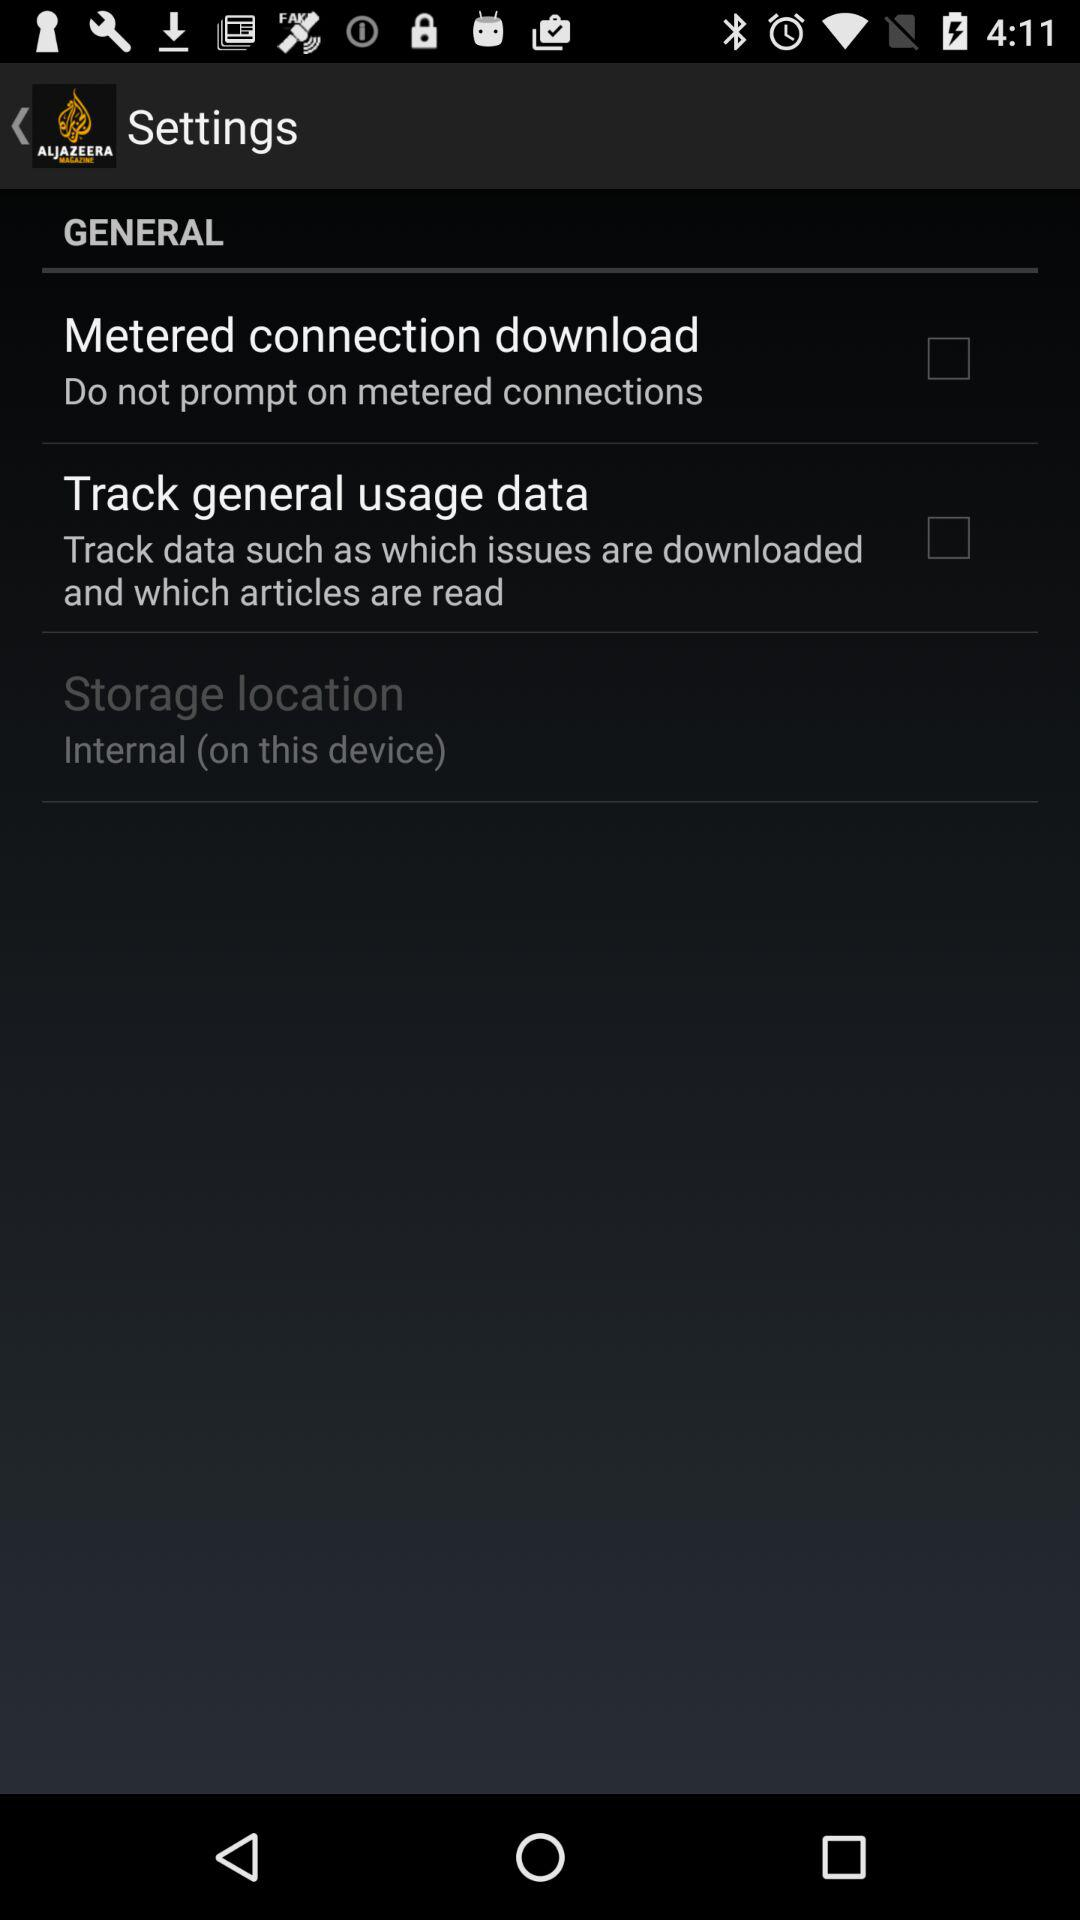What is the name of the application? The name of the application is "Al Jazeera English Magazine". 